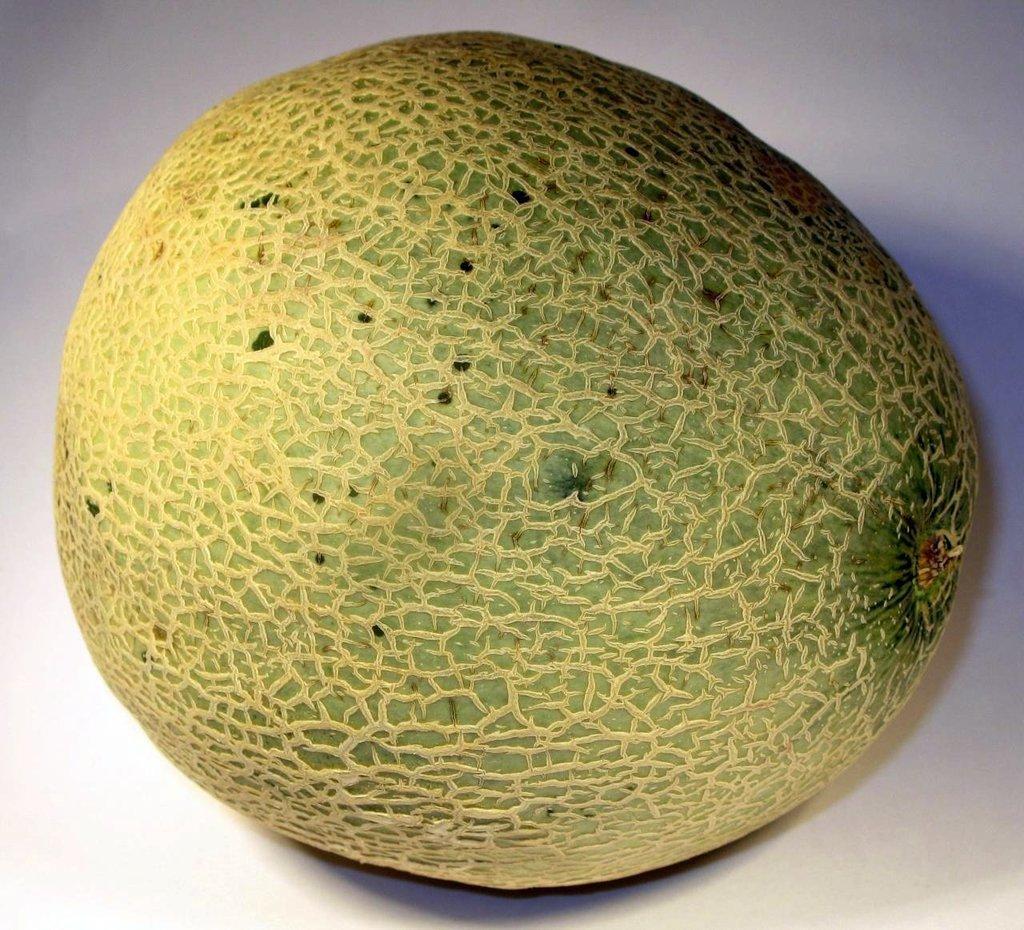Could you give a brief overview of what you see in this image? In this picture we can see a fruit on the white surface. In the background of the image it is white. 